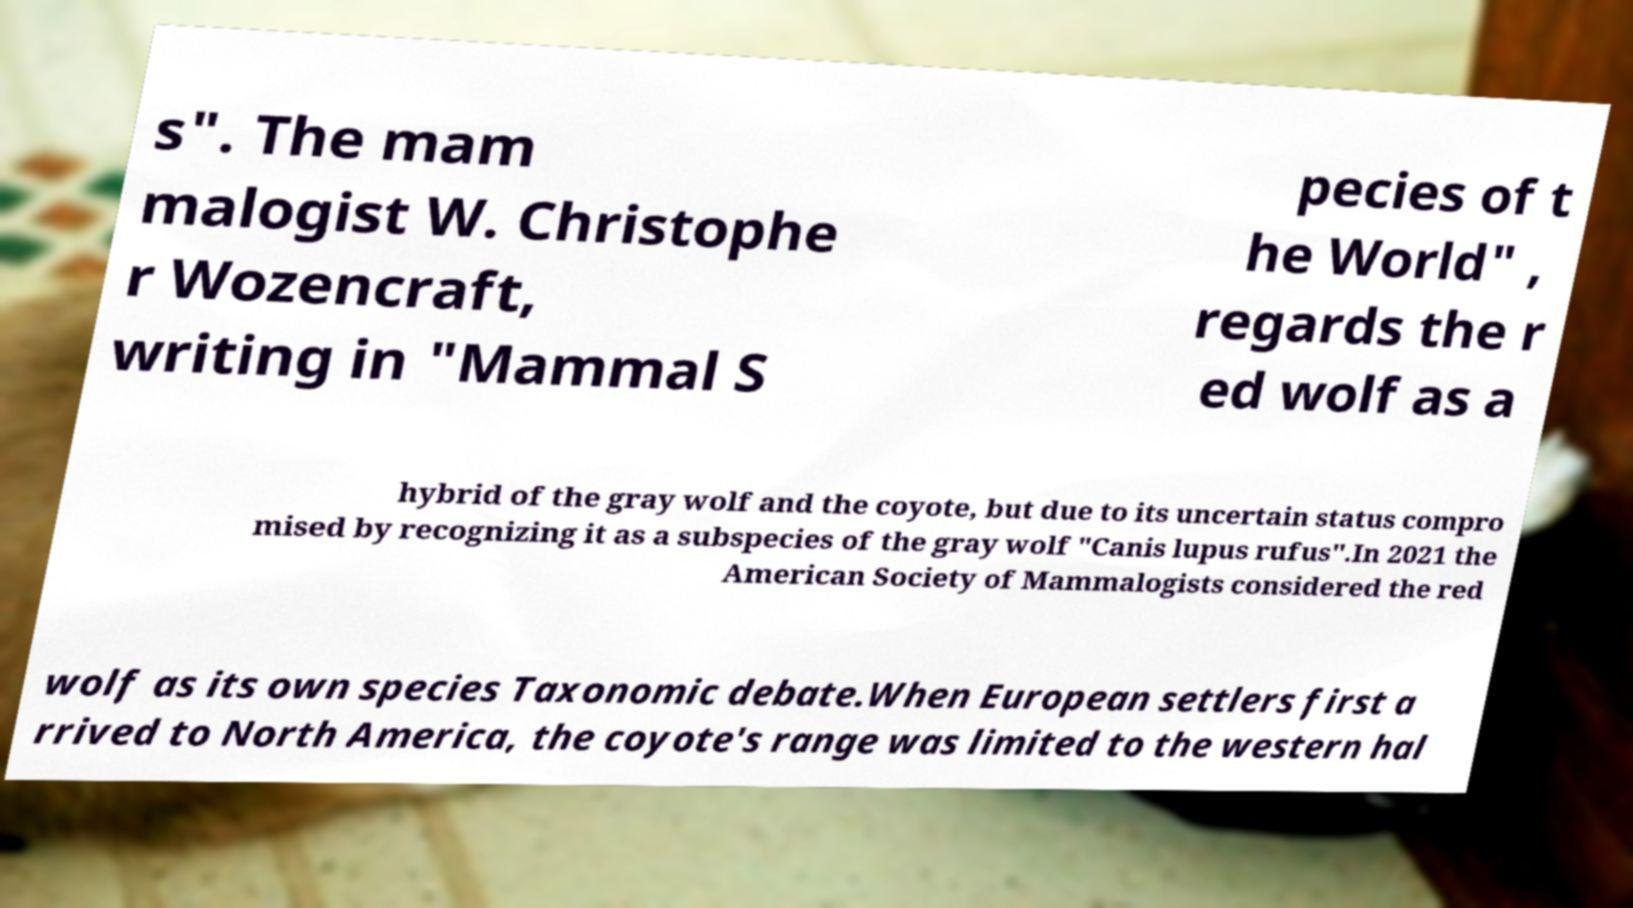I need the written content from this picture converted into text. Can you do that? s". The mam malogist W. Christophe r Wozencraft, writing in "Mammal S pecies of t he World" , regards the r ed wolf as a hybrid of the gray wolf and the coyote, but due to its uncertain status compro mised by recognizing it as a subspecies of the gray wolf "Canis lupus rufus".In 2021 the American Society of Mammalogists considered the red wolf as its own species Taxonomic debate.When European settlers first a rrived to North America, the coyote's range was limited to the western hal 